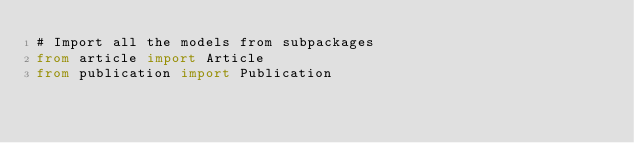<code> <loc_0><loc_0><loc_500><loc_500><_Python_># Import all the models from subpackages
from article import Article
from publication import Publication
</code> 